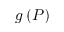Convert formula to latex. <formula><loc_0><loc_0><loc_500><loc_500>g \left ( P \right )</formula> 